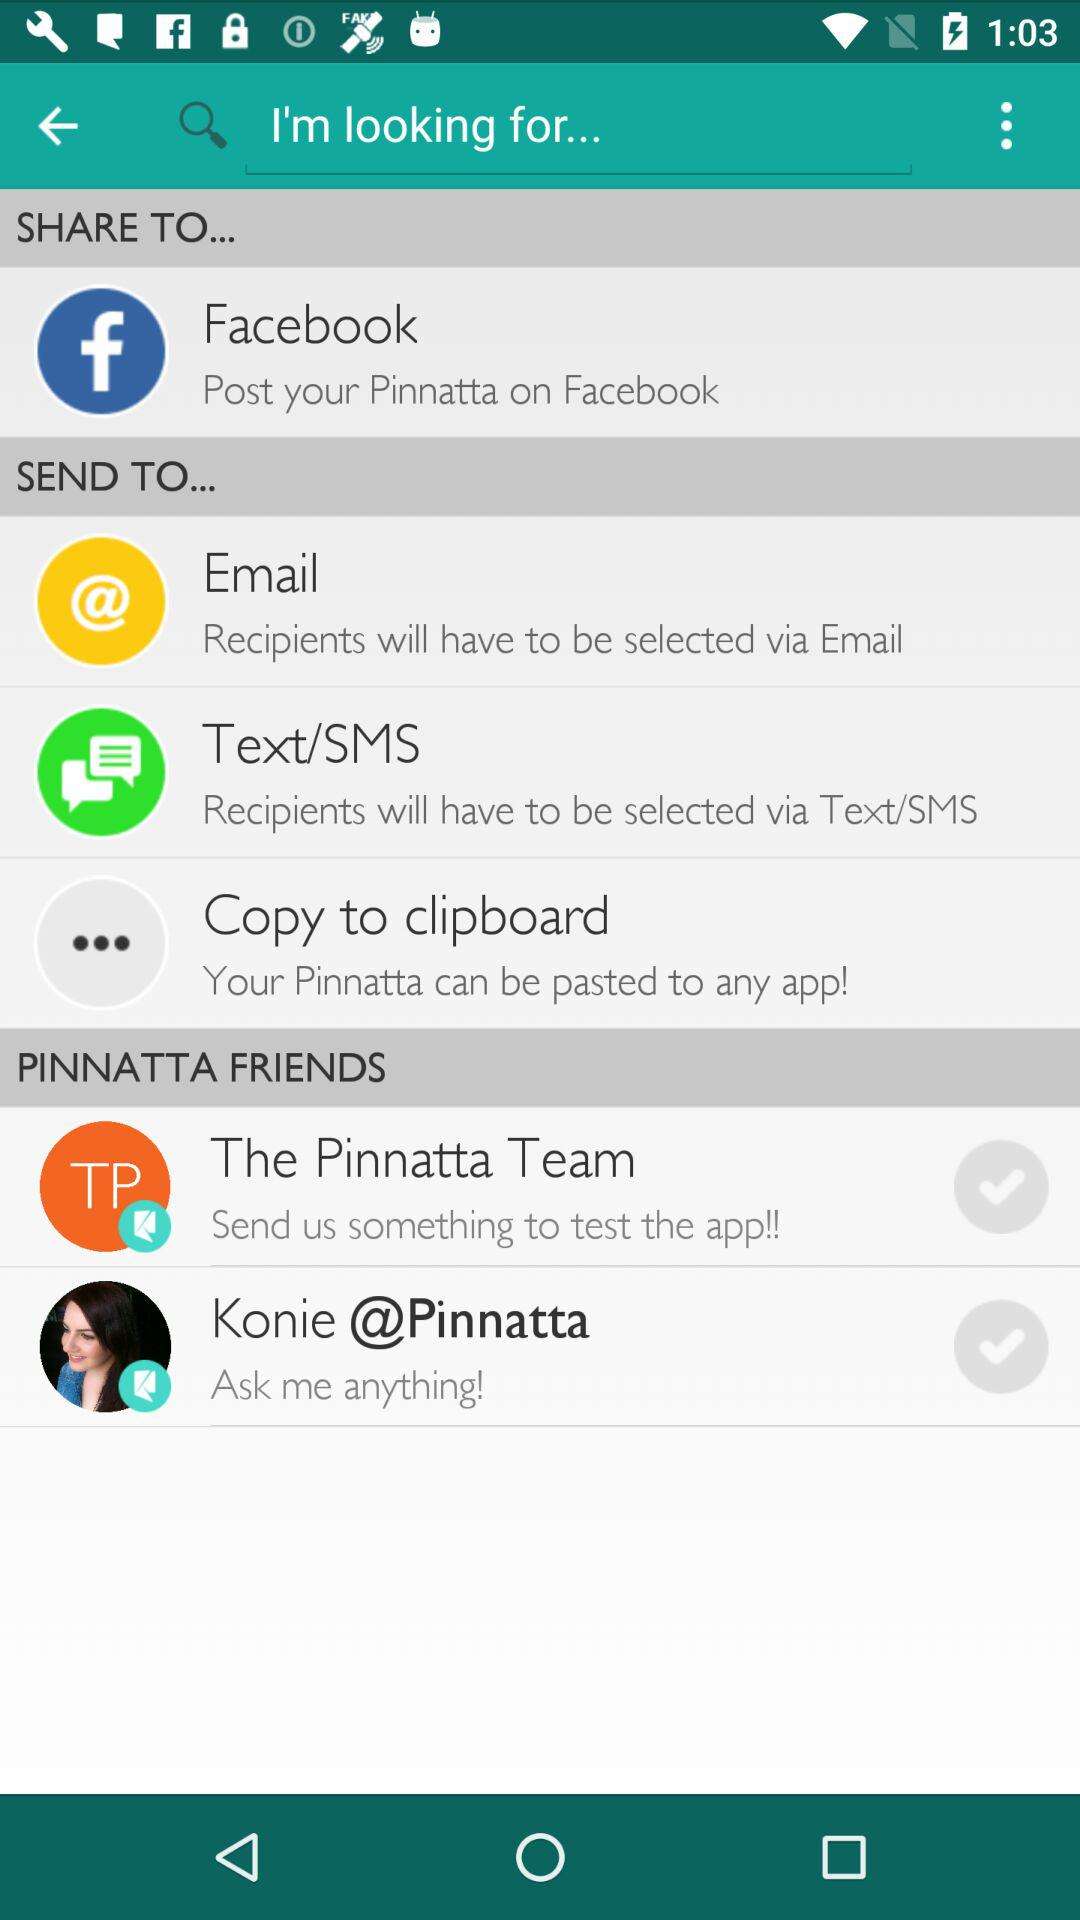What are the "Send to" options? The options are "Email", "Text/SMS", and "Copy to clipboard". 